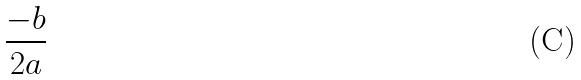<formula> <loc_0><loc_0><loc_500><loc_500>\frac { - b } { 2 a }</formula> 